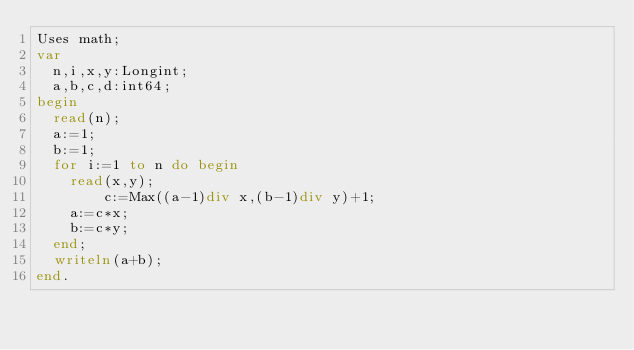Convert code to text. <code><loc_0><loc_0><loc_500><loc_500><_Pascal_>Uses math;
var
	n,i,x,y:Longint;
	a,b,c,d:int64;
begin
	read(n);
	a:=1;
	b:=1;
	for i:=1 to n do begin
		read(x,y);
        c:=Max((a-1)div x,(b-1)div y)+1;
		a:=c*x;
		b:=c*y;
	end;
	writeln(a+b);
end.
</code> 